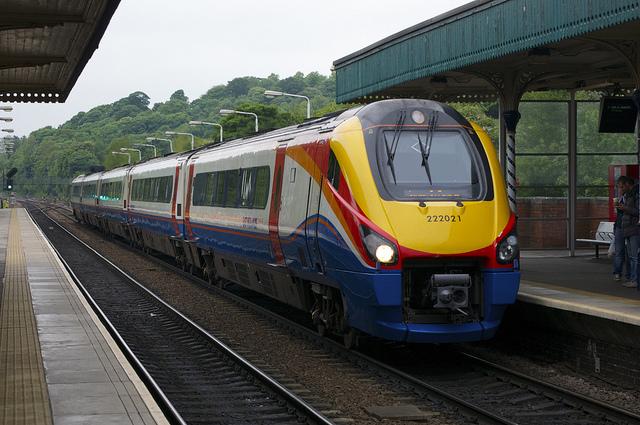Is the train currently stopped?
Keep it brief. Yes. Is this train run by electricity?
Be succinct. Yes. How many headlights are on?
Quick response, please. 1. Which headlight is not working?
Concise answer only. Left. 